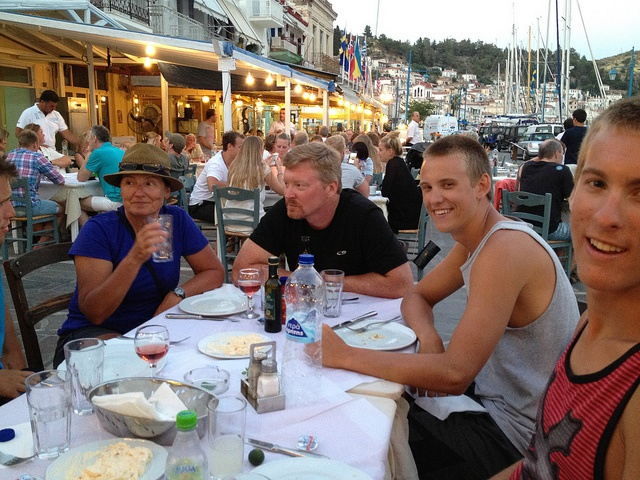Describe the objects in this image and their specific colors. I can see dining table in lightblue, lavender, and darkgray tones, people in lightblue, brown, black, gray, and maroon tones, people in lightblue, maroon, brown, and black tones, people in lightblue, black, gray, and maroon tones, and people in lightblue, black, maroon, navy, and brown tones in this image. 